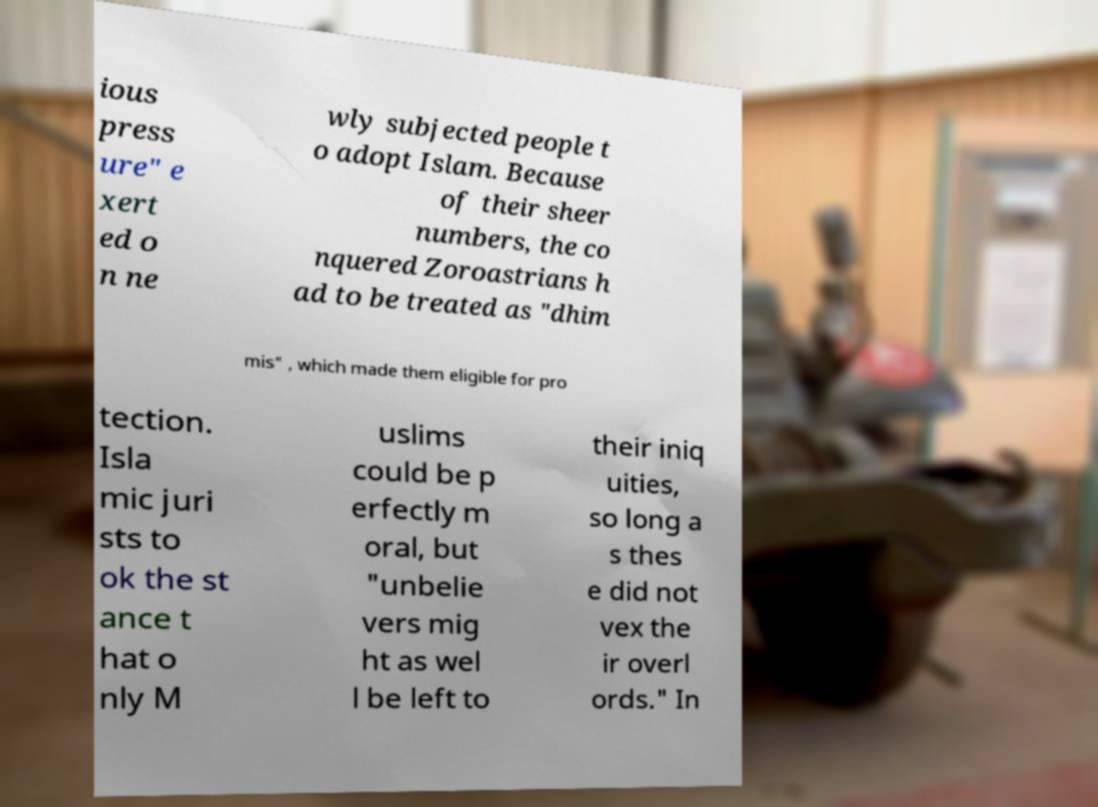Could you extract and type out the text from this image? ious press ure" e xert ed o n ne wly subjected people t o adopt Islam. Because of their sheer numbers, the co nquered Zoroastrians h ad to be treated as "dhim mis" , which made them eligible for pro tection. Isla mic juri sts to ok the st ance t hat o nly M uslims could be p erfectly m oral, but "unbelie vers mig ht as wel l be left to their iniq uities, so long a s thes e did not vex the ir overl ords." In 